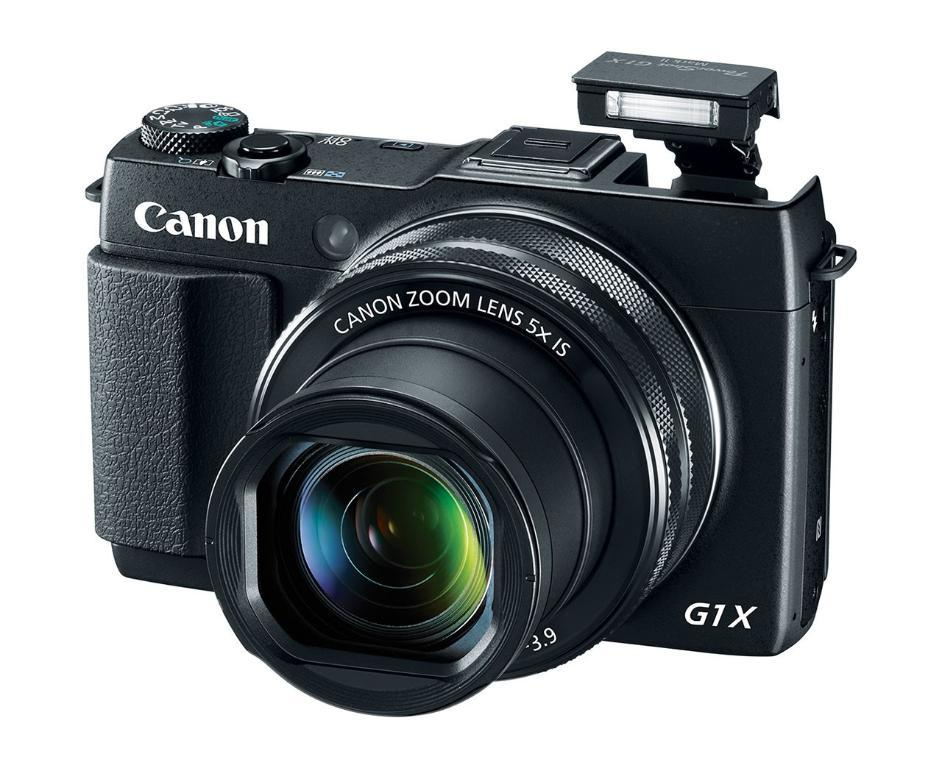What object is the main focus of the image? There is a camera in the image. Can you describe the color of the camera? The camera is black in color. What type of request can be seen being made by the camera in the image? There is no request being made by the camera in the image, as cameras do not have the ability to make requests. 